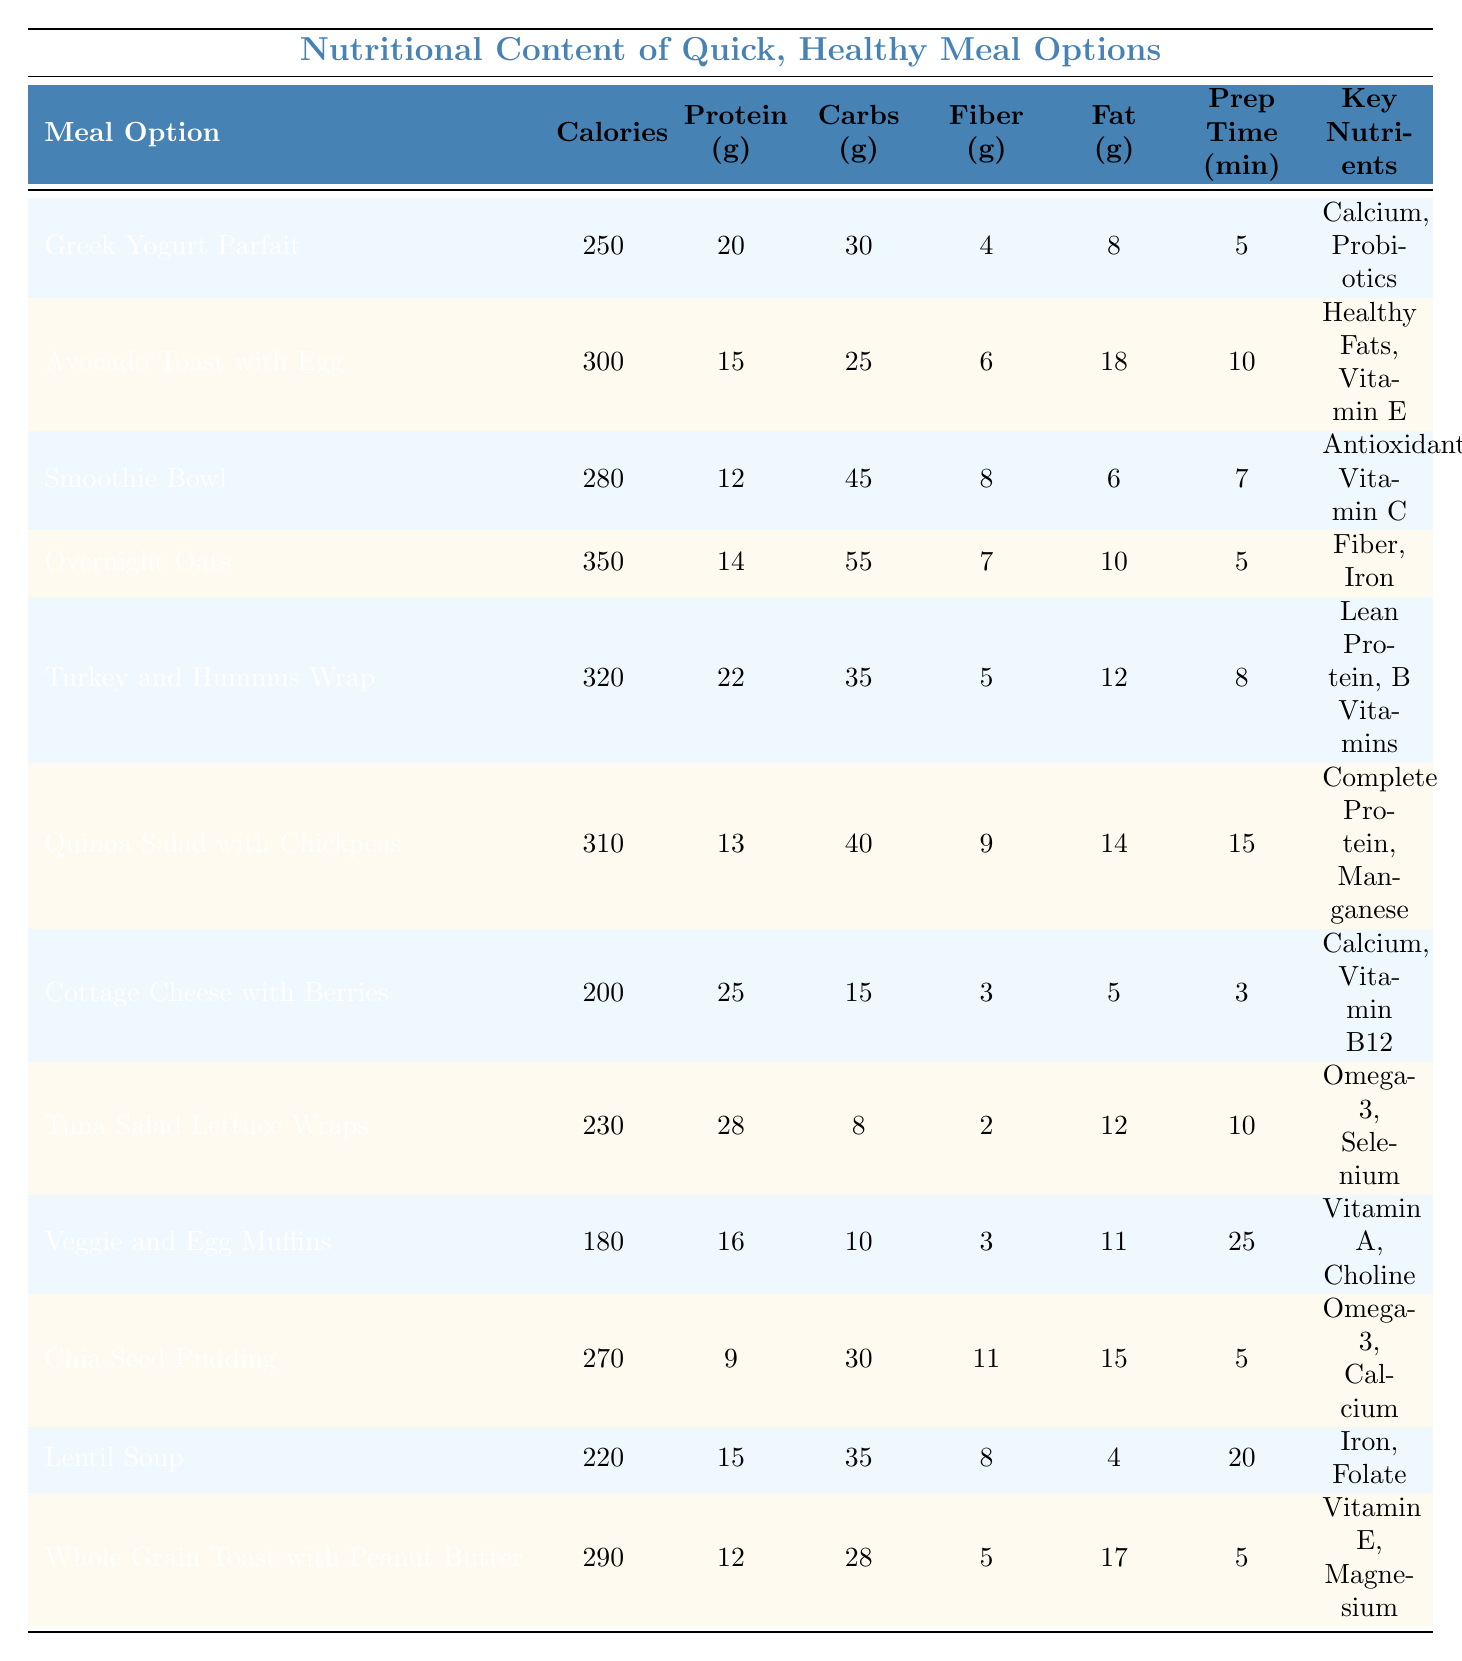What is the meal option with the highest protein content? Looking at the Protein column, "Tuna Salad Lettuce Wraps" has the highest value at 28 grams.
Answer: Tuna Salad Lettuce Wraps Which meal option has the least amount of calories? By checking the Calories column, "Veggie and Egg Muffins" has the lowest calorie count of 180.
Answer: Veggie and Egg Muffins What is the total amount of fiber in the "Overnight Oats" and "Chia Seed Pudding"? For "Overnight Oats", the fiber is 7 grams, and for "Chia Seed Pudding," it is 11 grams. Adding these gives 7 + 11 = 18 grams of fiber.
Answer: 18 grams Is "Turkey and Hummus Wrap" higher in calories than "Avocado Toast with Egg"? The calorie content for "Turkey and Hummus Wrap" is 320 and for "Avocado Toast with Egg" is 300. Since 320 is greater than 300, the statement is true.
Answer: Yes Which meal option requires the most preparation time? The Prep Time column shows "Veggie and Egg Muffins" with a preparation time of 25 minutes, which is the highest.
Answer: Veggie and Egg Muffins Calculate the average calories of the meal options listed. The total calories for all meal options are (250 + 300 + 280 + 350 + 320 + 310 + 200 + 230 + 180 + 270 + 220 + 290) = 3,030. Since there are 12 meal options, dividing 3,030 by 12 gives an average of 252.5 calories.
Answer: 252.5 calories Does "Cottage Cheese with Berries" provide more protein than "Chia Seed Pudding"? "Cottage Cheese with Berries" contains 25 grams of protein, while "Chia Seed Pudding" has 9 grams. Since 25 is greater than 9, the statement is true.
Answer: Yes What is the total prep time for the "Greek Yogurt Parfait" and "Smoothie Bowl"? "Greek Yogurt Parfait" has a prep time of 5 minutes and "Smoothie Bowl" has 7 minutes. Adding these gives 5 + 7 = 12 minutes total prep time.
Answer: 12 minutes What key nutrient is found in the "Quinoa Salad with Chickpeas"? The Key Nutrients column lists "Complete Protein, Manganese" for the "Quinoa Salad with Chickpeas."
Answer: Complete Protein, Manganese Which meal has the highest fat content? By reviewing the Fat column, "Avocado Toast with Egg" shows the highest at 18 grams.
Answer: Avocado Toast with Egg What is the difference in carbohydrates between "Whole Grain Toast with Peanut Butter" and "Lentil Soup"? "Whole Grain Toast with Peanut Butter" has 28 grams of carbohydrates and "Lentil Soup" has 35 grams. The difference is 35 - 28 = 7 grams.
Answer: 7 grams 